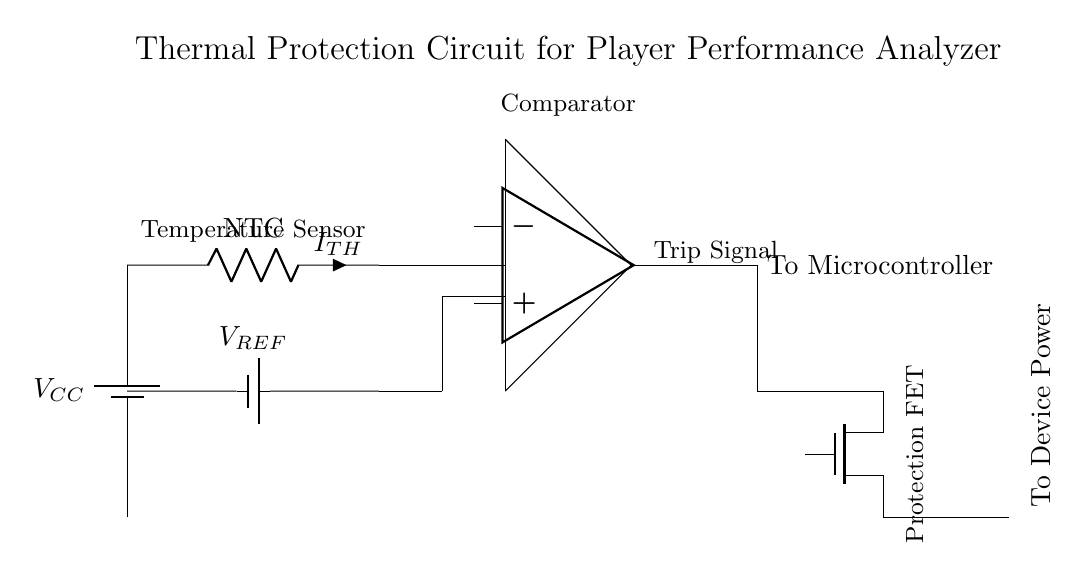What component regulates temperature? The thermistor, labeled as NTC, is responsible for regulating temperature by changing its resistance with temperature variations.
Answer: Thermistor What is the reference voltage labeled as? The reference voltage in the circuit is labeled as V_REF, indicating a specified voltage level used for comparison with the input voltage from the thermistor.
Answer: V_REF What is the output connected to? The output of the comparator is connected to the microcontroller, as indicated in the circuit. This connection allows the microcontroller to receive the trip signal for processing.
Answer: To Microcontroller What type of FET is used for protection? The protection FET used in the circuit is a Trench MOSFET, indicated by the notation Tnmos, which is designed to protect the device from thermal issues.
Answer: Trench MOSFET How does the comparator function in this circuit? The comparator compares the output of the thermistor circuit against the reference voltage. If the thermistor indicates a temperature above a threshold, the comparator outputs a trip signal to the microcontroller, which signals the protection FET to cut off power to the device.
Answer: It compares temperatures What happens if the temperature exceeds the threshold? If the temperature exceeds the threshold, the comparator outputs a trip signal, activating the protection FET to disconnect power to the device, thereby preventing damage from overheating.
Answer: Power disconnects What is the current flowing through the thermistor labeled as? The current flowing through the thermistor is labeled as I_TH, which indicates the amount of current that flows through the NTC thermistor during operation.
Answer: I_TH 